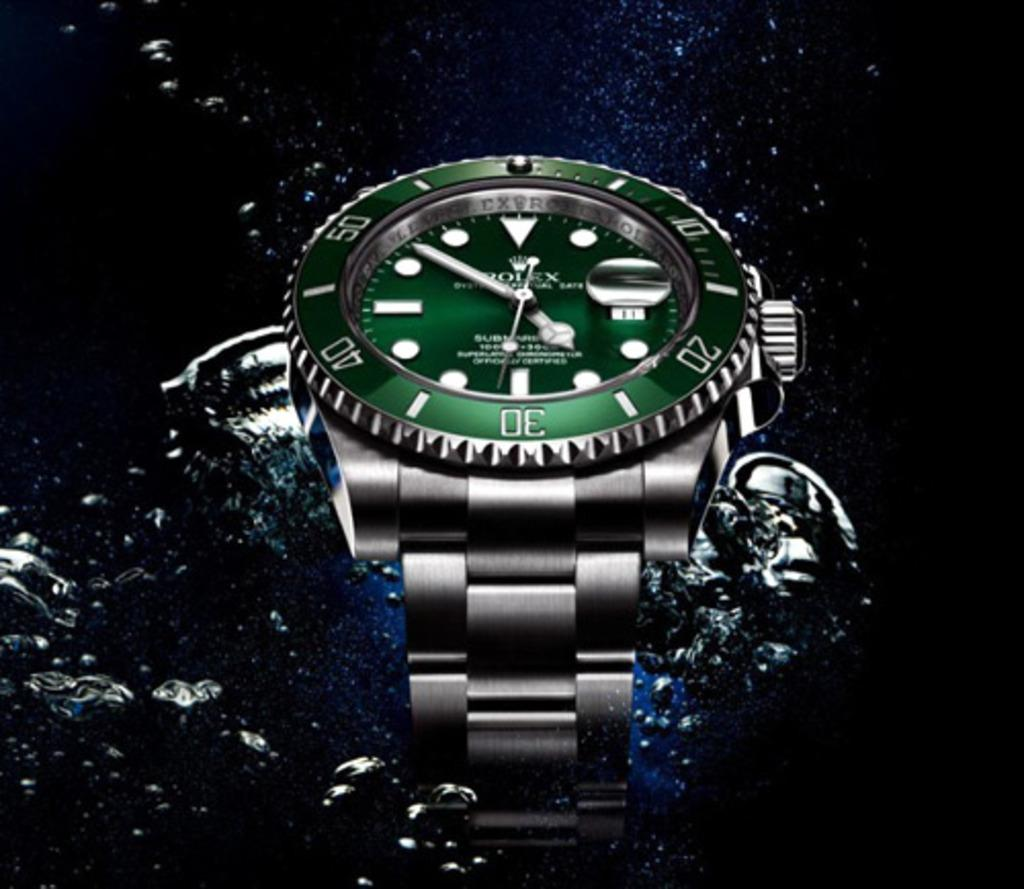<image>
Present a compact description of the photo's key features. A Rolex brand watch has a green face. 